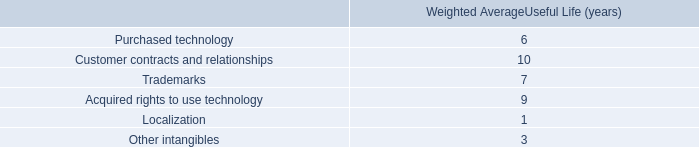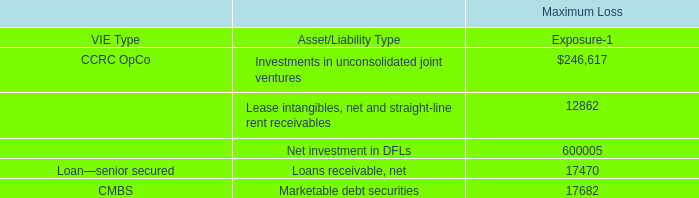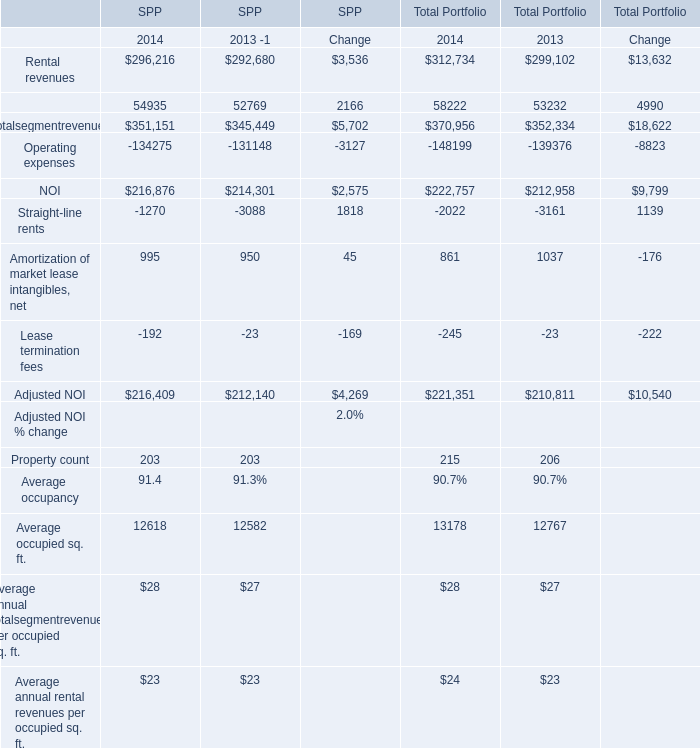what was average weighted average useful life ( years ) for customer contracts and relationships and trademarks? 
Computations: ((10 + 7) / 2)
Answer: 8.5. 